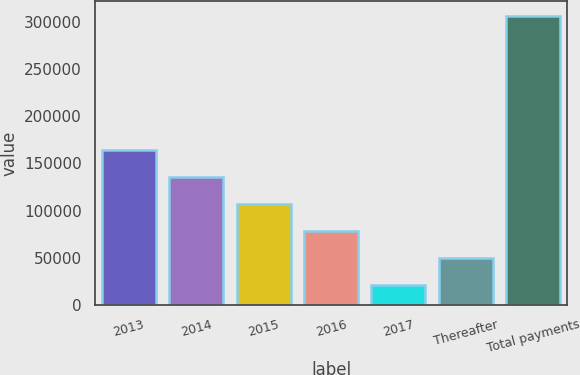Convert chart to OTSL. <chart><loc_0><loc_0><loc_500><loc_500><bar_chart><fcel>2013<fcel>2014<fcel>2015<fcel>2016<fcel>2017<fcel>Thereafter<fcel>Total payments<nl><fcel>164042<fcel>135516<fcel>106991<fcel>78465.6<fcel>21415<fcel>49940.3<fcel>306668<nl></chart> 